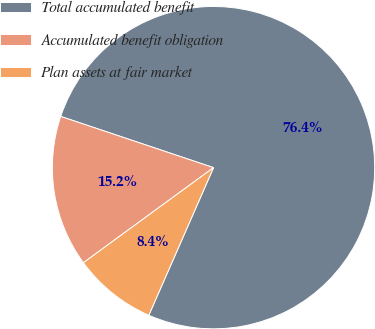<chart> <loc_0><loc_0><loc_500><loc_500><pie_chart><fcel>Total accumulated benefit<fcel>Accumulated benefit obligation<fcel>Plan assets at fair market<nl><fcel>76.43%<fcel>15.19%<fcel>8.38%<nl></chart> 